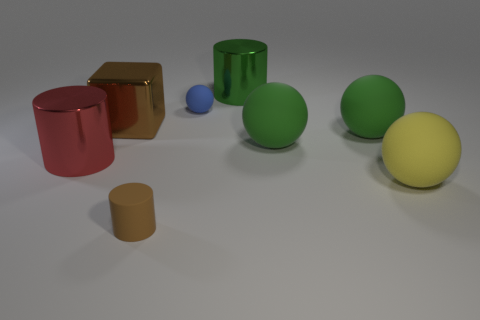Add 1 yellow balls. How many objects exist? 9 Subtract all cylinders. How many objects are left? 5 Subtract all green metallic objects. Subtract all small things. How many objects are left? 5 Add 2 blue things. How many blue things are left? 3 Add 2 tiny gray matte balls. How many tiny gray matte balls exist? 2 Subtract 1 brown cylinders. How many objects are left? 7 